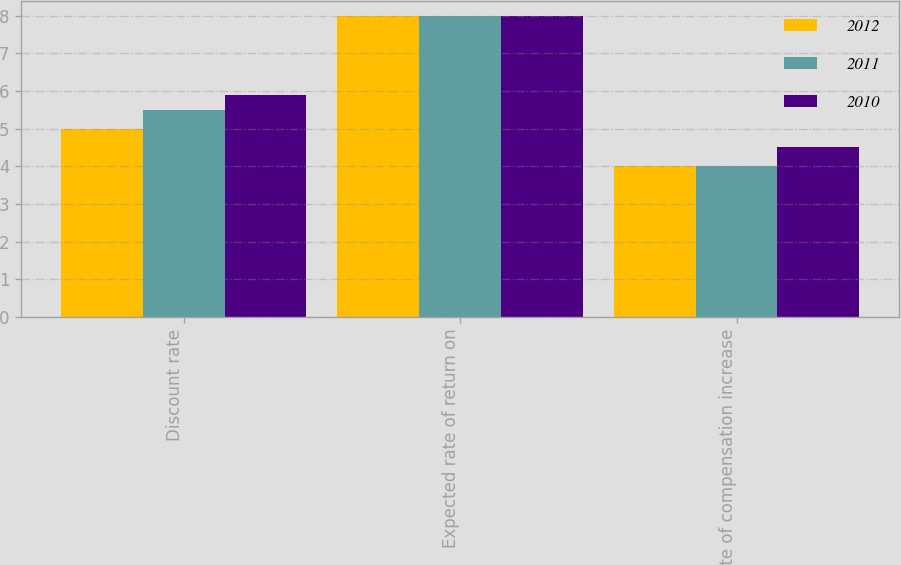Convert chart. <chart><loc_0><loc_0><loc_500><loc_500><stacked_bar_chart><ecel><fcel>Discount rate<fcel>Expected rate of return on<fcel>Rate of compensation increase<nl><fcel>2012<fcel>5<fcel>8<fcel>4<nl><fcel>2011<fcel>5.5<fcel>8<fcel>4<nl><fcel>2010<fcel>5.9<fcel>8<fcel>4.5<nl></chart> 